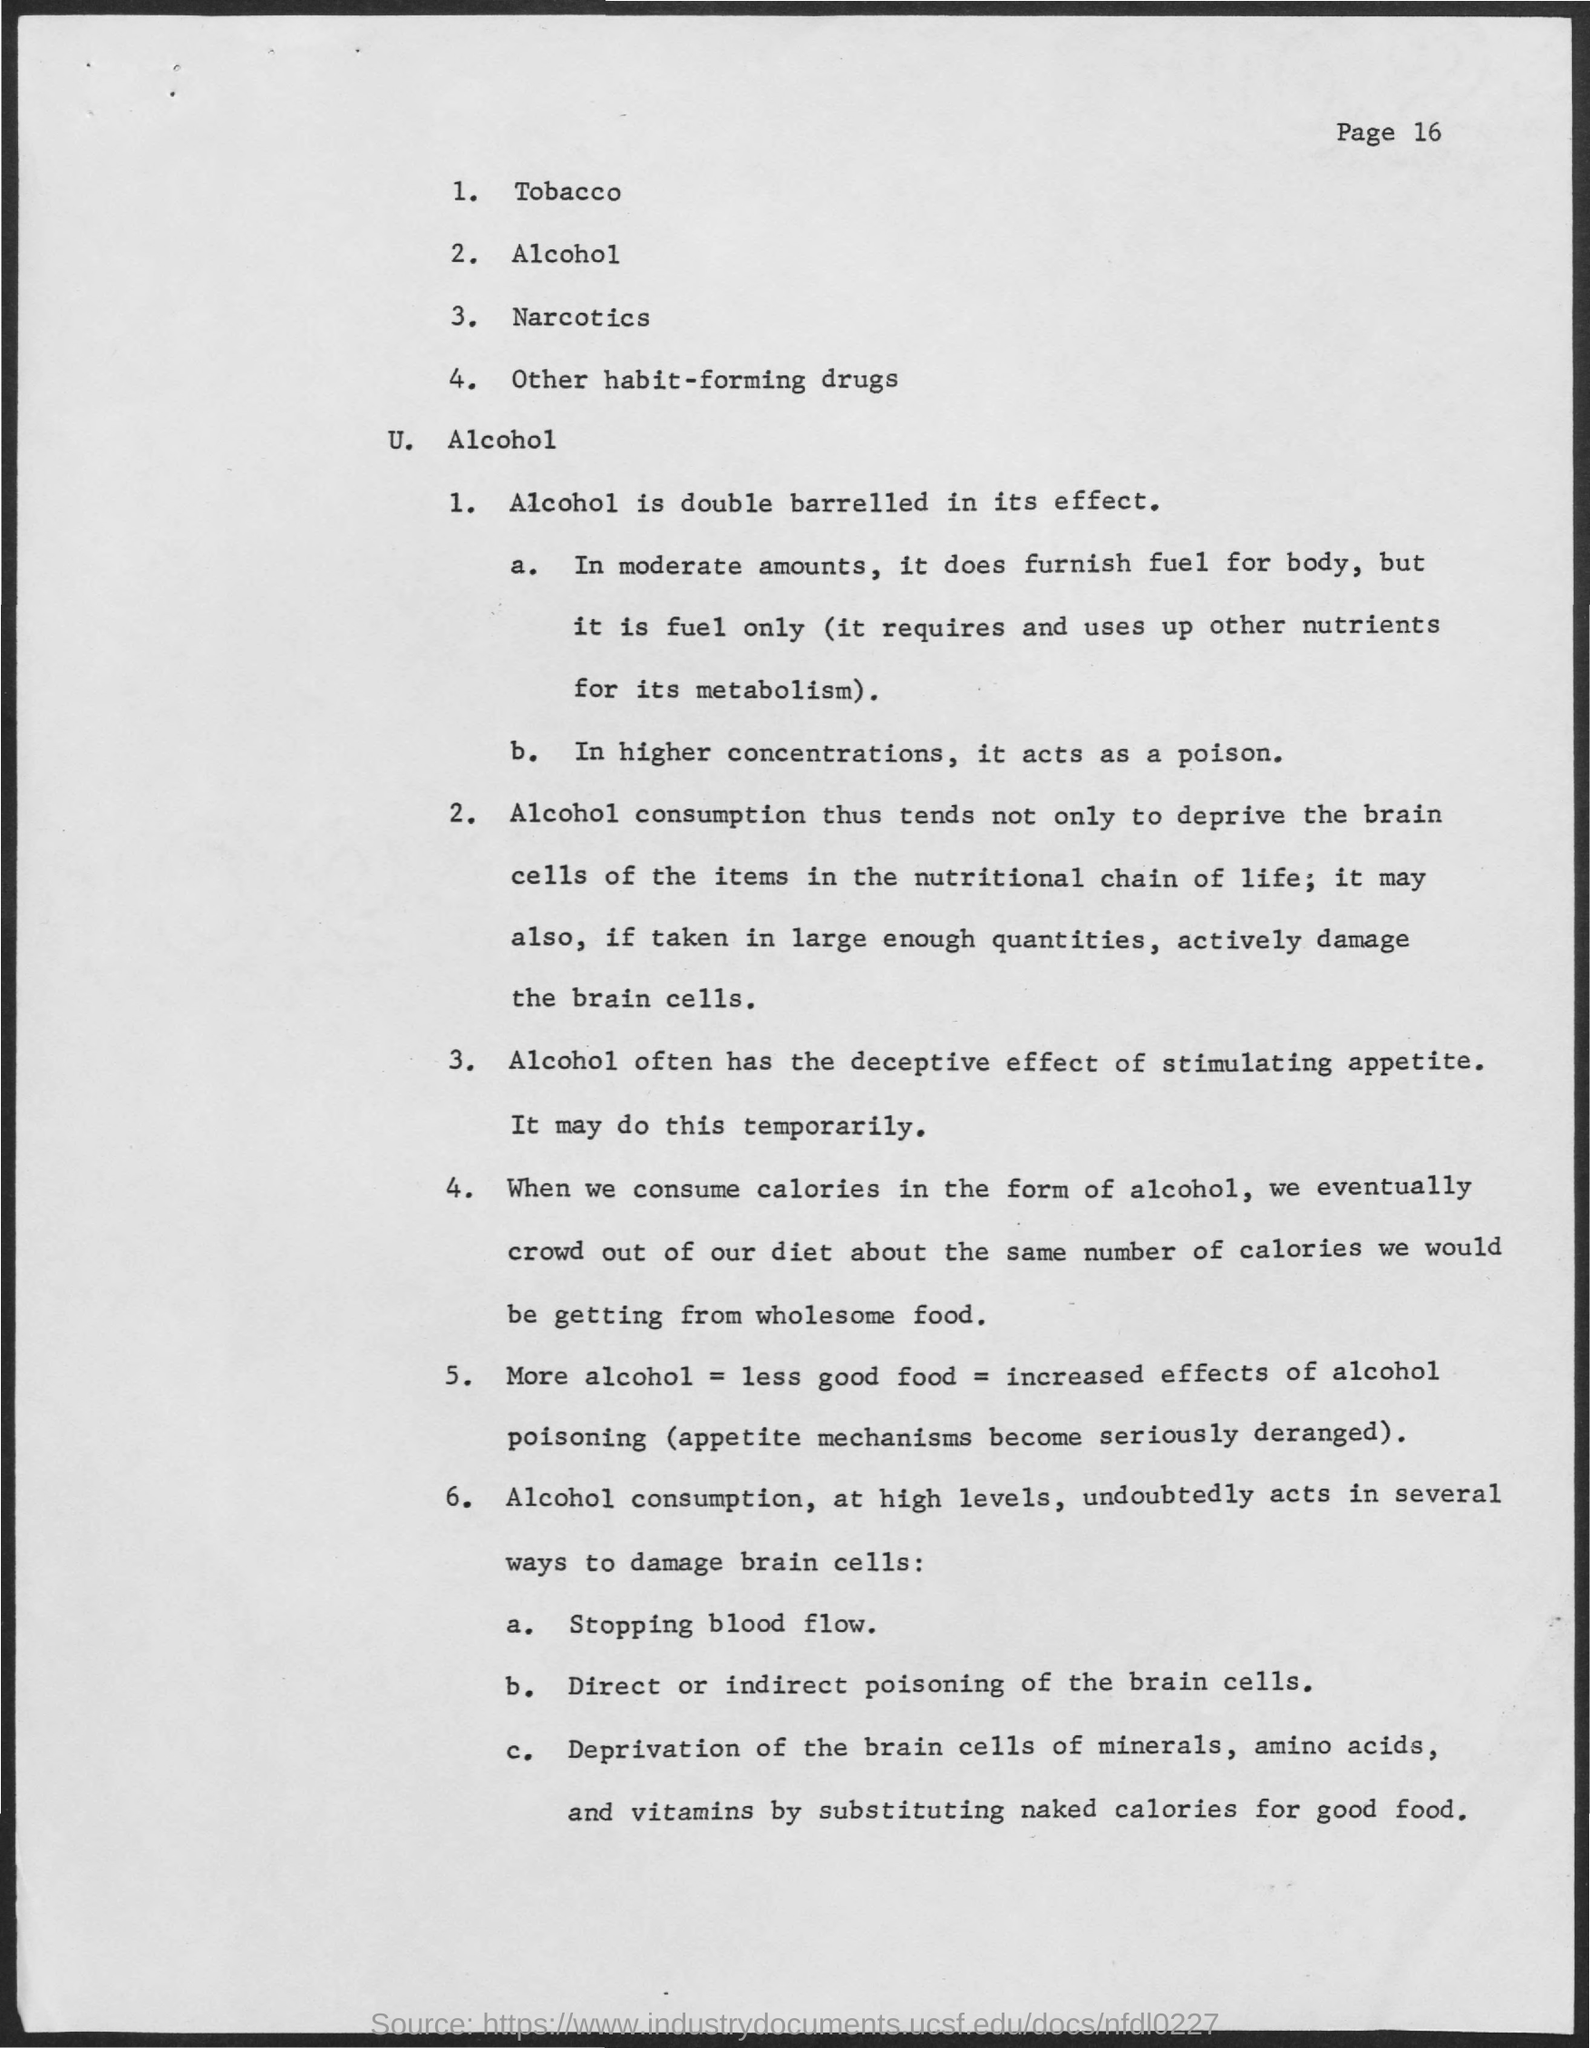What is the Page number given at the top right corner of the page?
Your answer should be compact. 16. As mentioned in point "1" under Alcohol, How is  ALCOHOL in its effect?
Ensure brevity in your answer.  Double barrelled. "In higher concentrations , alcohol acts as what?
Your response must be concise. Poison. What substance,"if taken in large enough quantities,actively damage the  brain cells?
Give a very brief answer. Alcohol. Often alcohol has what "deceptive effect"?
Your answer should be compact. Of stimulating appetite. "Alcohol consumption, at high levels", causes "Direct or Indirect poisoning" of which cells?
Keep it short and to the point. Brain cells. "Alcohol consumption, at high levels", causes "Deprivation of the brain cells " of which all  substances?
Give a very brief answer. Of minerals, amino acids and vitamins. 